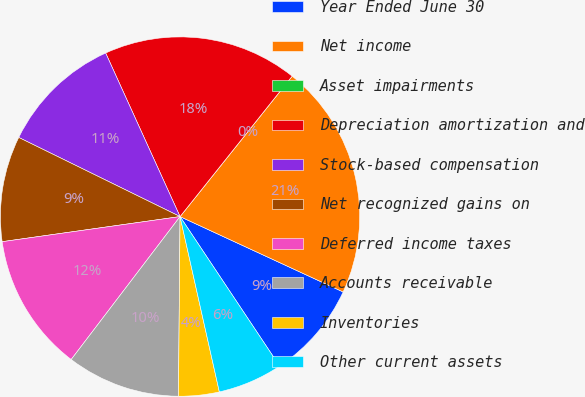Convert chart. <chart><loc_0><loc_0><loc_500><loc_500><pie_chart><fcel>Year Ended June 30<fcel>Net income<fcel>Asset impairments<fcel>Depreciation amortization and<fcel>Stock-based compensation<fcel>Net recognized gains on<fcel>Deferred income taxes<fcel>Accounts receivable<fcel>Inventories<fcel>Other current assets<nl><fcel>8.76%<fcel>21.17%<fcel>0.0%<fcel>17.52%<fcel>10.95%<fcel>9.49%<fcel>12.41%<fcel>10.22%<fcel>3.65%<fcel>5.84%<nl></chart> 